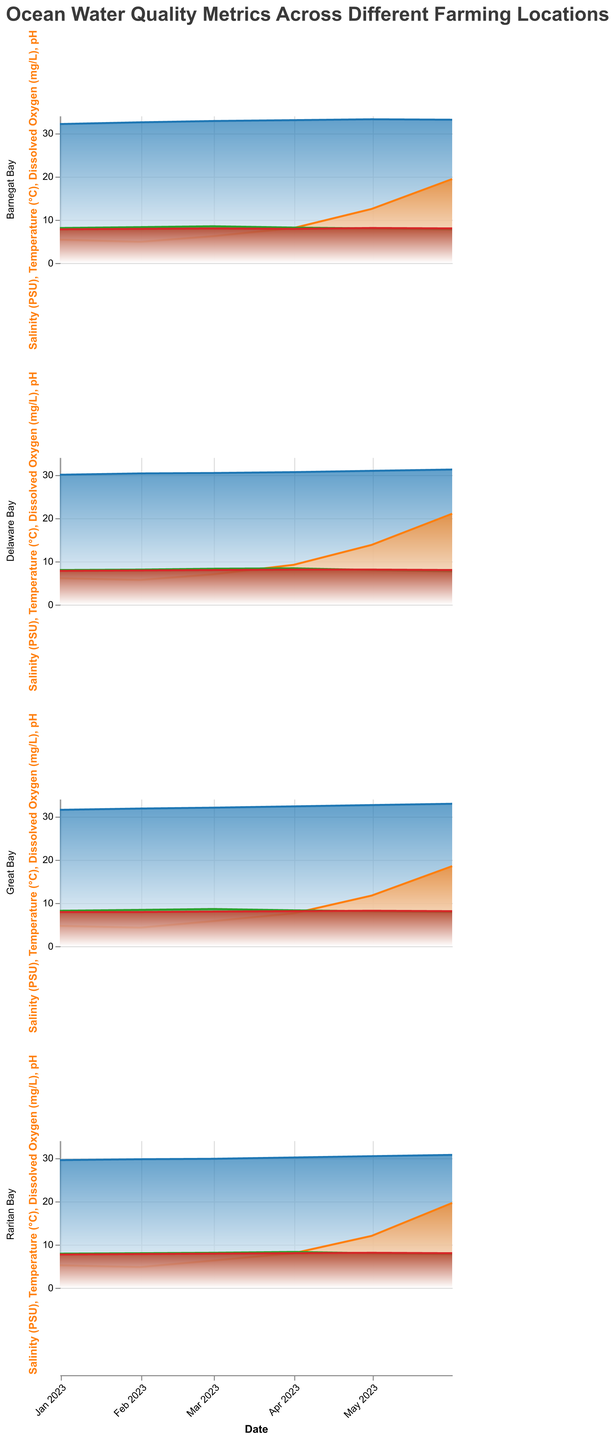What is the title of the figure? The title is located at the top of the figure, and it summarizes what the figure is about.
Answer: Ocean Water Quality Metrics Across Different Farming Locations Which location has the lowest salinity in January 2023? By looking at the salinity (PSU) values for January 2023 across different locations, we can compare them to determine the lowest. Raritan Bay has a salinity of 29.5, which is the lowest among the locations.
Answer: Raritan Bay How does the temperature trend in Delaware Bay change from January to June 2023? Observe the temperature (C) area chart for Delaware Bay. From January to June, the temperature rises gradually from 6.1°C to 21.0°C.
Answer: Increases Which month does Great Bay show the highest dissolved oxygen level in 2023? Look at the dissolved oxygen (mg/L) area chart for Great Bay. The highest value is 8.6 mg/L in March 2023.
Answer: March 2023 What is the average pH level in Barnegat Bay over the observed months? To find the average pH in Barnegat Bay, sum all pH levels and divide by the number of months. (7.8 + 7.9 + 8.0 + 7.9 + 8.1 + 8.0) / 6 = 47.7 / 6 = 7.95.
Answer: 7.95 Compare the dissolved oxygen levels in Raritan Bay and Delaware Bay during April 2023. Which bay has a higher level, and by how much? Check the dissolved oxygen (mg/L) values for both locations in April 2023. Raritan Bay has 8.3 mg/L, and Delaware Bay has 8.4 mg/L. The difference is 8.4 - 8.3 = 0.1 mg/L.
Answer: Delaware Bay, 0.1 mg/L In which month does the temperature in Great Bay first exceed 10°C? Look at the temperature (C) values for Great Bay across months. The first occurrence above 10°C is in May 2023 with a value of 11.7°C.
Answer: May 2023 How does the salinity trend in Barnegat Bay compare to that in Delaware Bay from January to June 2023? Compare the salinity (PSU) trends for both locations. Barnegat Bay's salinity rises slightly from 32.1 to 33.1, while Delaware Bay's salinity also rises but starts lower from 30.0 to 31.2. The overall trend in both cases is increasing.
Answer: Both increasing What is the range of pH levels across all locations in June 2023? Identify the highest and lowest pH levels in June 2023 across all locations. The pH values range from 8.0 to 8.1.
Answer: 8.0 to 8.1 Which location showed the greatest increase in temperature from January to June 2023, and what is the difference? Calculate the temperature difference for each location over the given months. Barnegat Bay (19.4 - 5.4), Delaware Bay (21.0 - 6.1), Great Bay (18.5 - 4.7), Raritan Bay (19.6 - 5.2). Delaware Bay shows the greatest increase with a difference of 14.9°C.
Answer: Delaware Bay, 14.9°C 